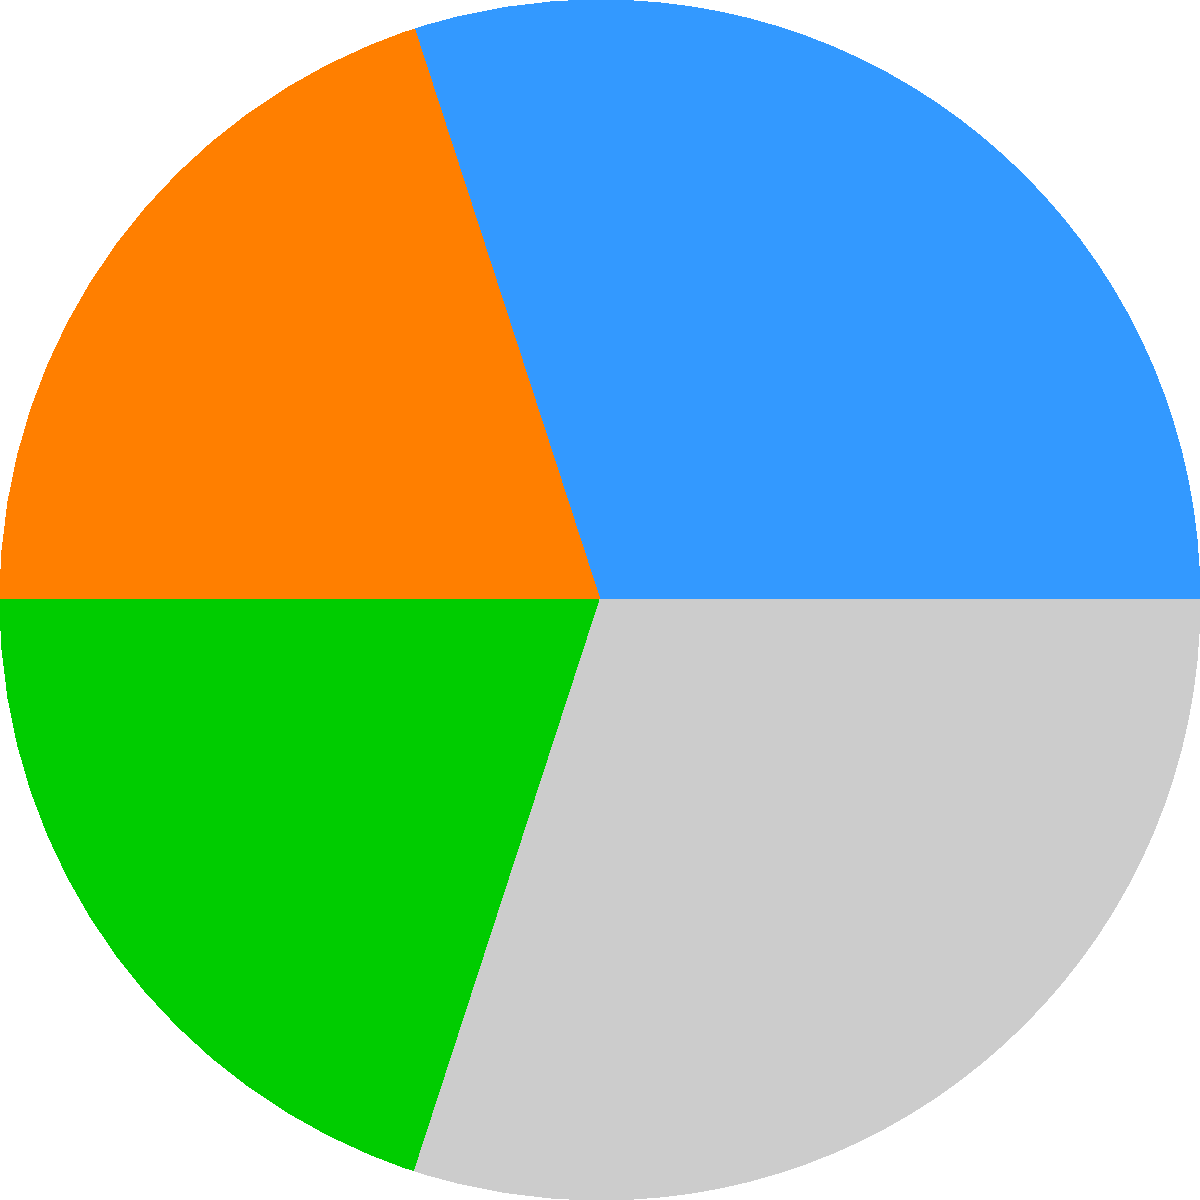The circular chart shows the market share of different energy sources in China's industrial sector. If the chart is dilated by a factor of 1.5, what is the new area of the sector representing natural gas compared to its original area? To solve this problem, we need to understand how dilation affects the area of a two-dimensional shape:

1. The dilation factor is 1.5.
2. For two-dimensional shapes, the area is affected by the square of the dilation factor.
3. Let's call the original area of the natural gas sector $A$.
4. The new area after dilation will be: $A_{new} = (1.5)^2 \times A$
5. Simplifying: $A_{new} = 2.25 \times A$
6. This means the new area is 2.25 times the original area.

Therefore, the new area of the sector representing natural gas is 2.25 times its original area.
Answer: 2.25 times the original area 